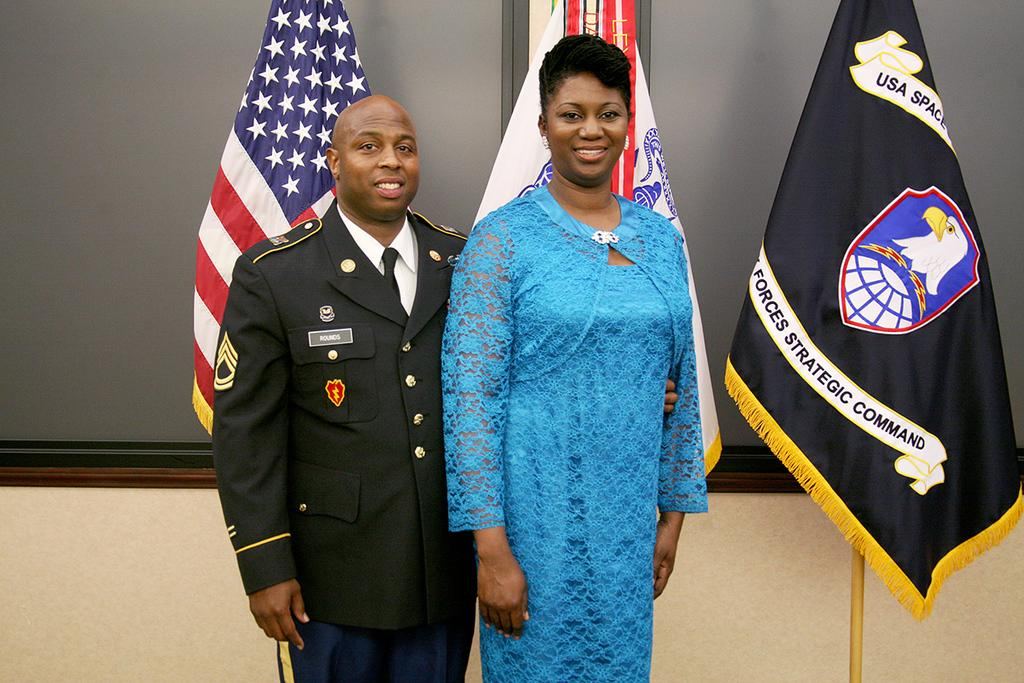<image>
Describe the image concisely. Soldier and a woman posing in front of a flag that says "Forces Strategic Command". 